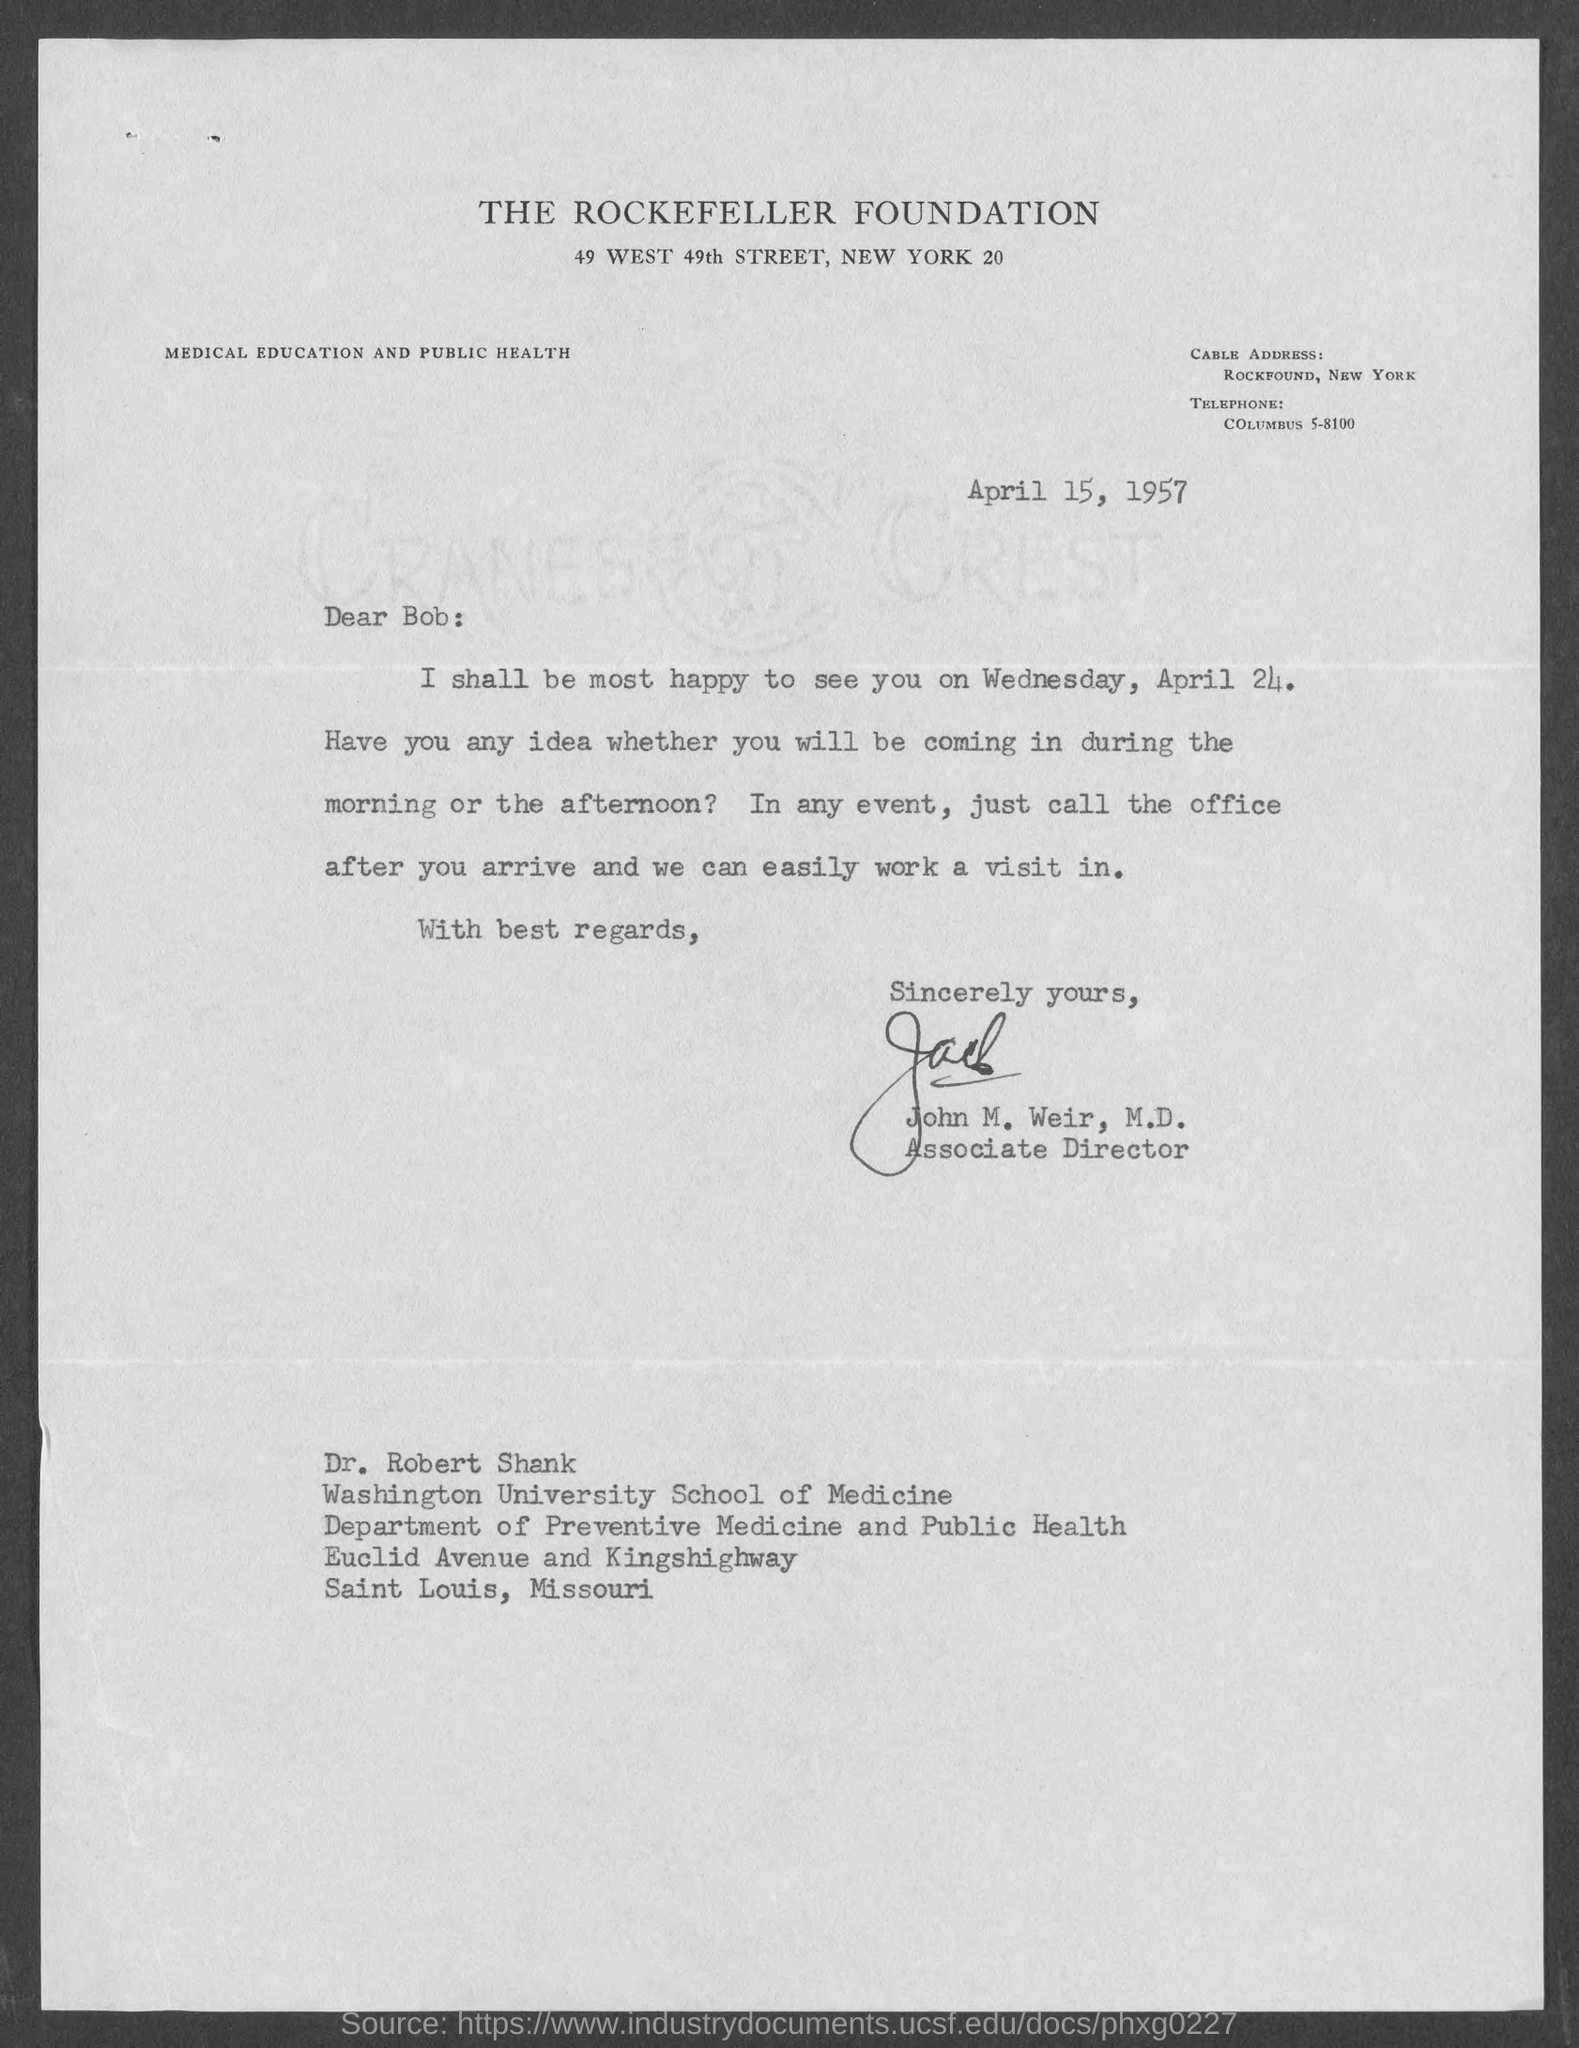Which organization is mentioned in the letterhead?
Give a very brief answer. The Rockefeller Foundation. What is the cable address given in the letter?
Your answer should be very brief. Rockfound, New York. What is the issued date of the letter?
Offer a very short reply. April 15, 1957. Who is the sender of this letter?
Offer a very short reply. John M. Weir, M.D. What is the designation of John M. Weir, M.D.?
Give a very brief answer. Associate Director. 